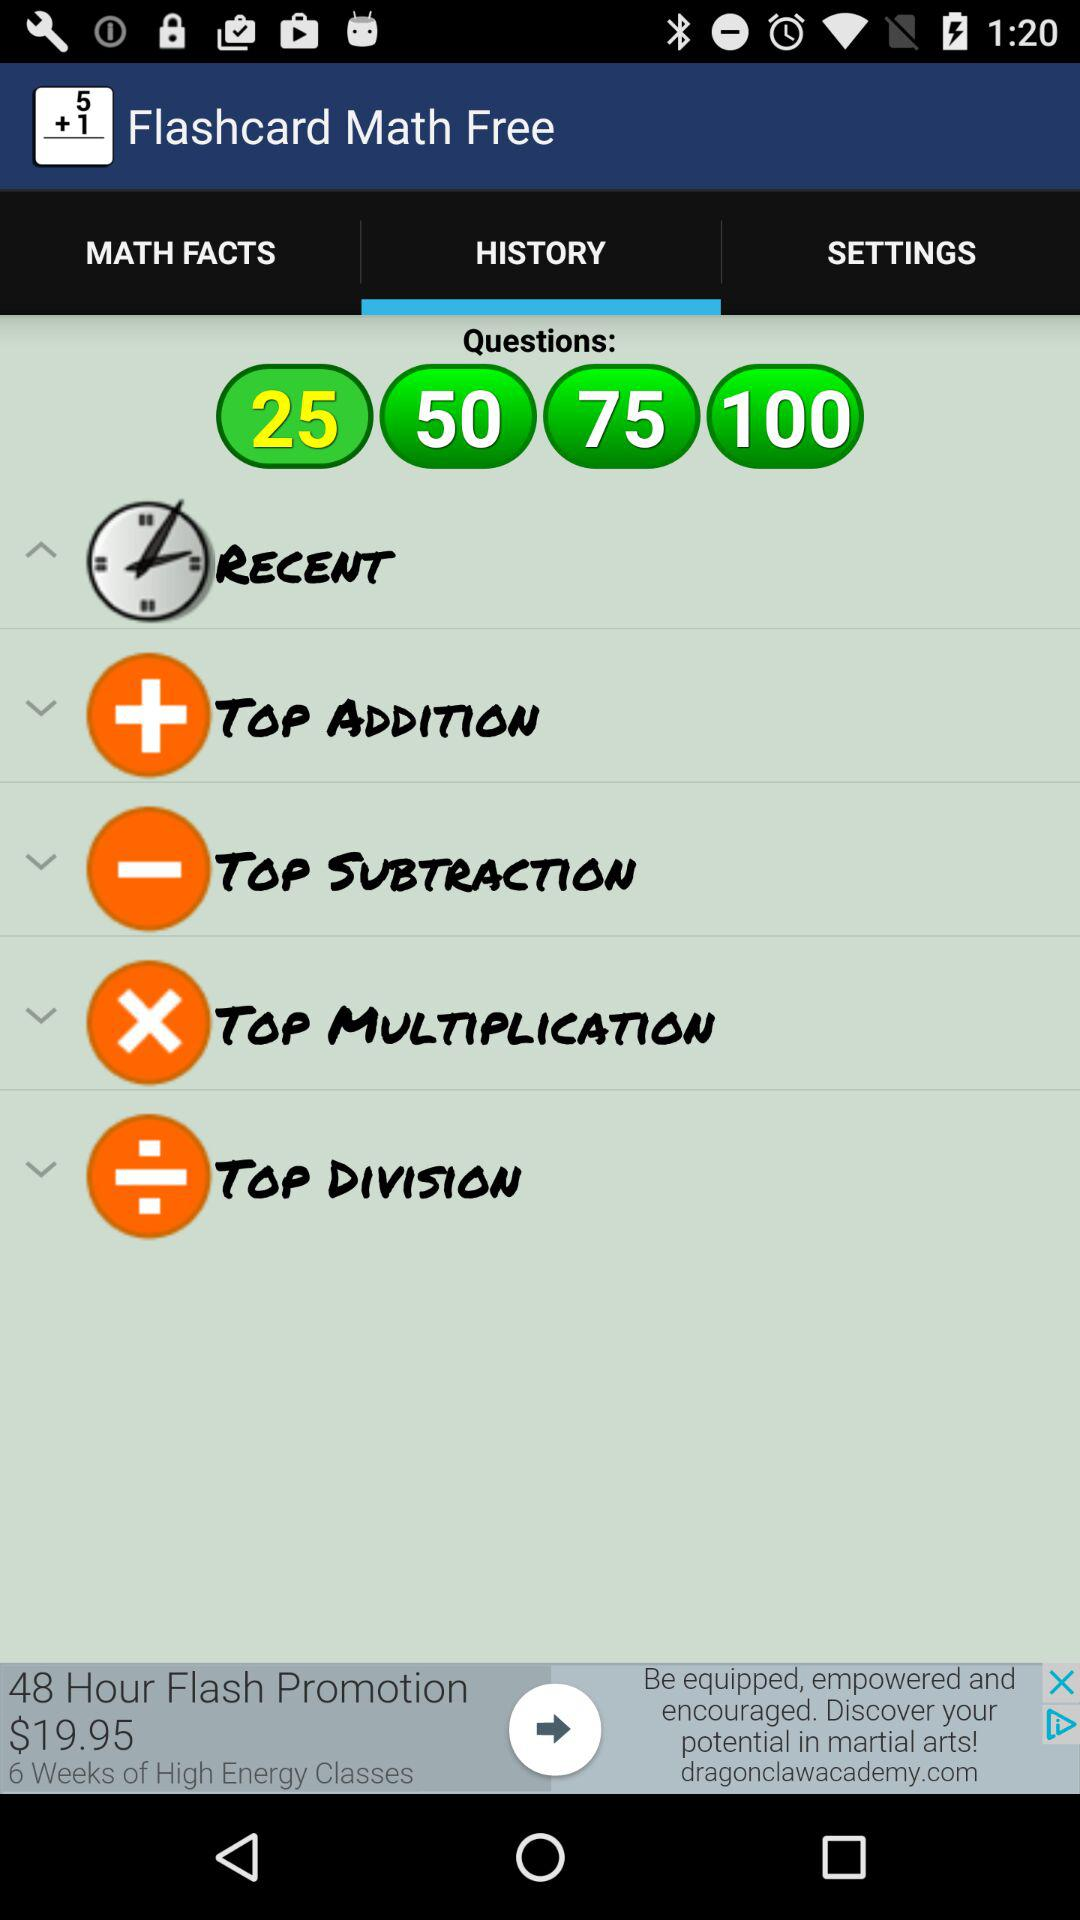Which option is selected in "Flashcard Math Free"? The selected options in "Flashcard Math Free" are "HISTORY" and "25". 